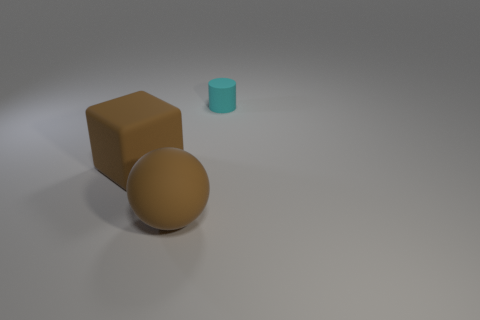The object that is the same color as the big matte sphere is what size?
Offer a terse response. Large. There is a object behind the big brown matte block behind the brown matte sphere; what shape is it?
Make the answer very short. Cylinder. How big is the object that is behind the rubber object that is on the left side of the large ball that is in front of the large brown rubber cube?
Your answer should be very brief. Small. Do the cyan cylinder and the brown rubber sphere have the same size?
Your answer should be compact. No. How many other things are there of the same shape as the cyan object?
Provide a short and direct response. 0. Are there any big brown things on the right side of the matte block?
Offer a very short reply. Yes. How many objects are big cyan metallic cubes or tiny cyan cylinders?
Make the answer very short. 1. What number of other things are the same size as the cyan object?
Offer a terse response. 0. How many things are both right of the big rubber cube and in front of the cyan matte object?
Offer a terse response. 1. Does the brown matte object to the left of the big matte ball have the same size as the brown thing in front of the brown rubber cube?
Offer a terse response. Yes. 